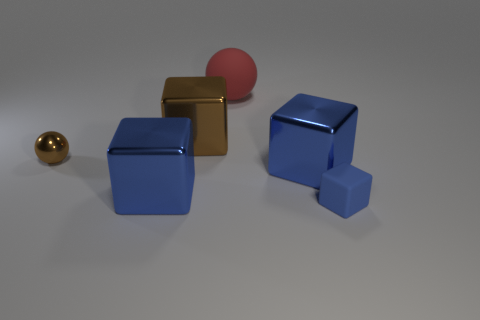Subtract all blue blocks. How many were subtracted if there are1blue blocks left? 2 Subtract all green balls. How many blue cubes are left? 3 Add 1 big purple metallic blocks. How many objects exist? 7 Subtract all tiny blue cubes. How many cubes are left? 3 Subtract all brown cubes. How many cubes are left? 3 Subtract 1 blocks. How many blocks are left? 3 Subtract all balls. How many objects are left? 4 Subtract all yellow spheres. Subtract all brown cylinders. How many spheres are left? 2 Subtract all blue metallic things. Subtract all rubber spheres. How many objects are left? 3 Add 4 blue metallic blocks. How many blue metallic blocks are left? 6 